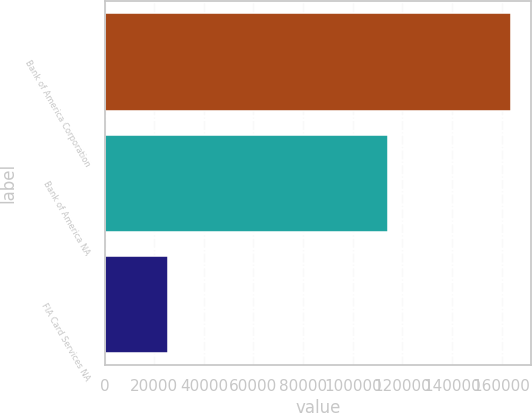Convert chart. <chart><loc_0><loc_0><loc_500><loc_500><bar_chart><fcel>Bank of America Corporation<fcel>Bank of America NA<fcel>FIA Card Services NA<nl><fcel>163626<fcel>114345<fcel>25589<nl></chart> 